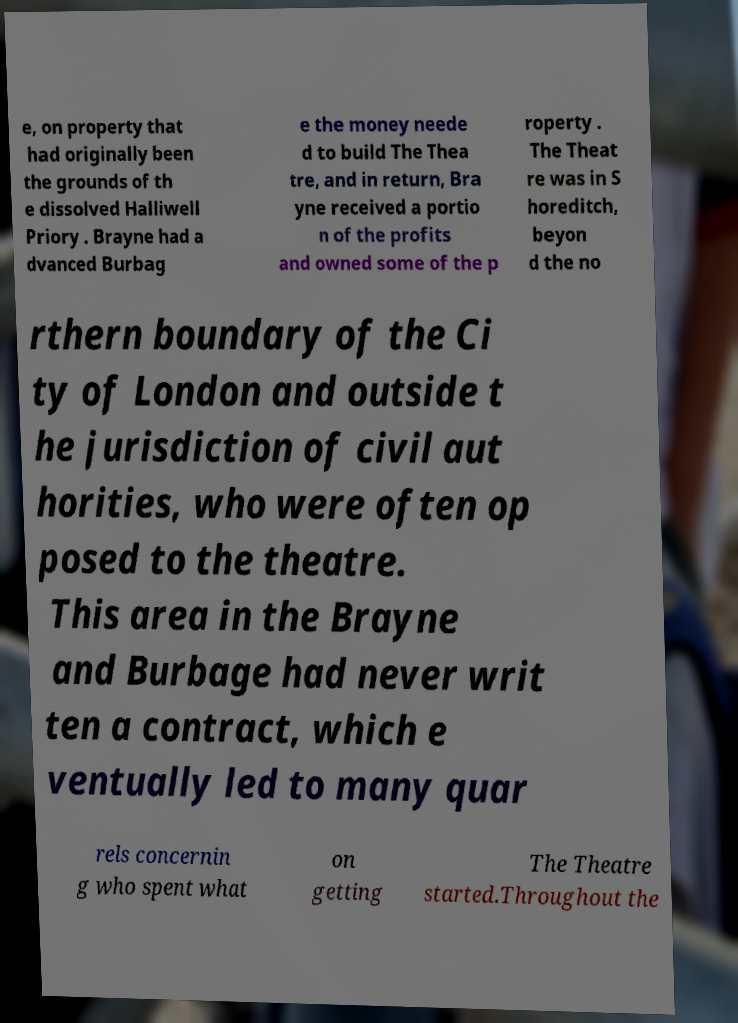For documentation purposes, I need the text within this image transcribed. Could you provide that? e, on property that had originally been the grounds of th e dissolved Halliwell Priory . Brayne had a dvanced Burbag e the money neede d to build The Thea tre, and in return, Bra yne received a portio n of the profits and owned some of the p roperty . The Theat re was in S horeditch, beyon d the no rthern boundary of the Ci ty of London and outside t he jurisdiction of civil aut horities, who were often op posed to the theatre. This area in the Brayne and Burbage had never writ ten a contract, which e ventually led to many quar rels concernin g who spent what on getting The Theatre started.Throughout the 